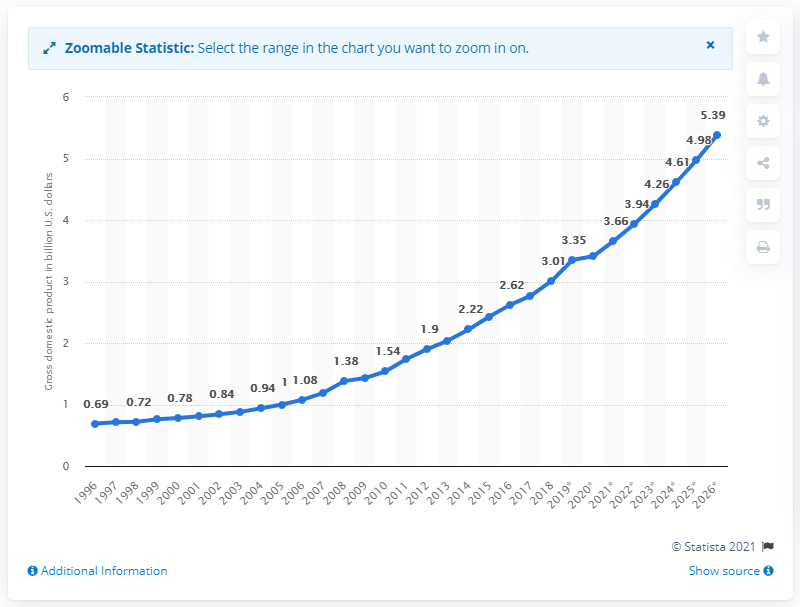Indicate a few pertinent items in this graphic. Djibouti's gross domestic product in 2018 was 3.01. 